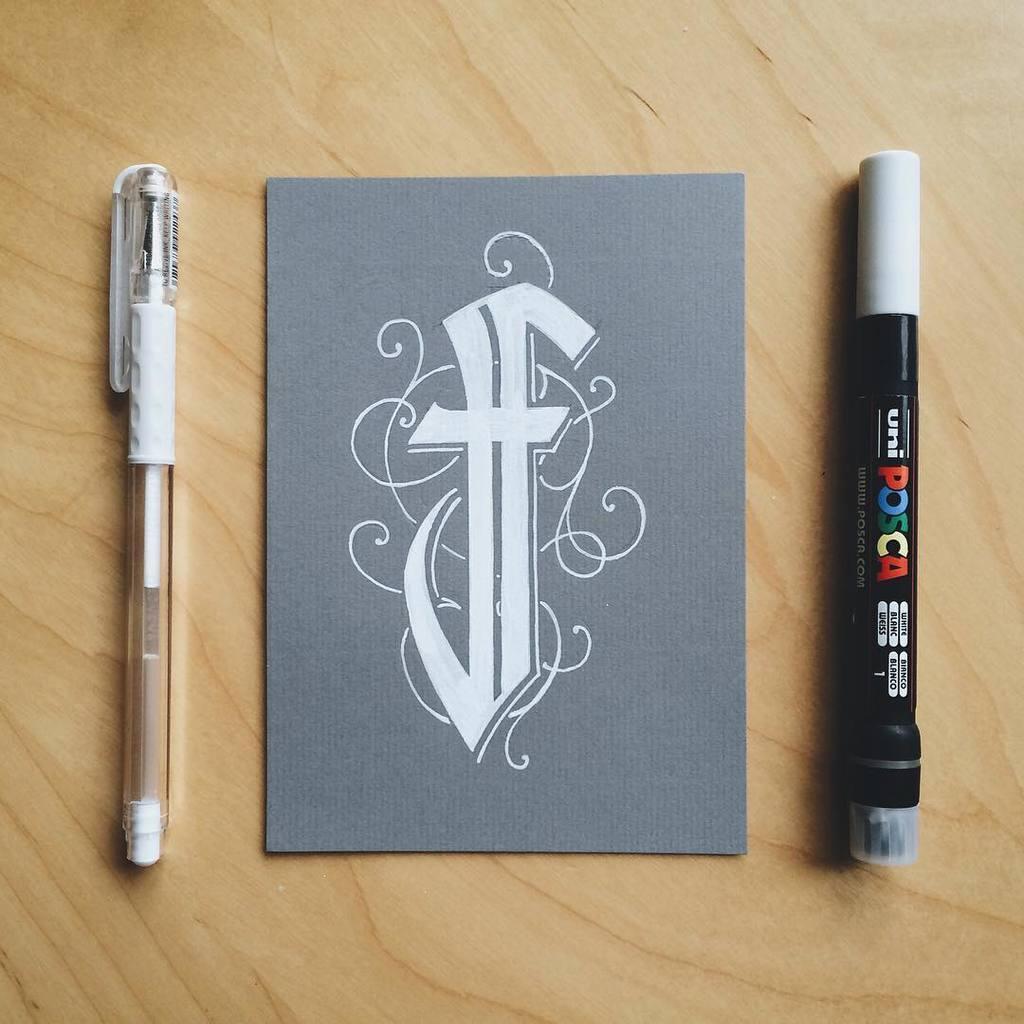Can you describe this image briefly? In this picture I see a grey color paper on which there is a logo and I see the pen on the left side of this paper and I see a marker on the right side of this paper and these 3 things are on the surface which is of light brown in color. 